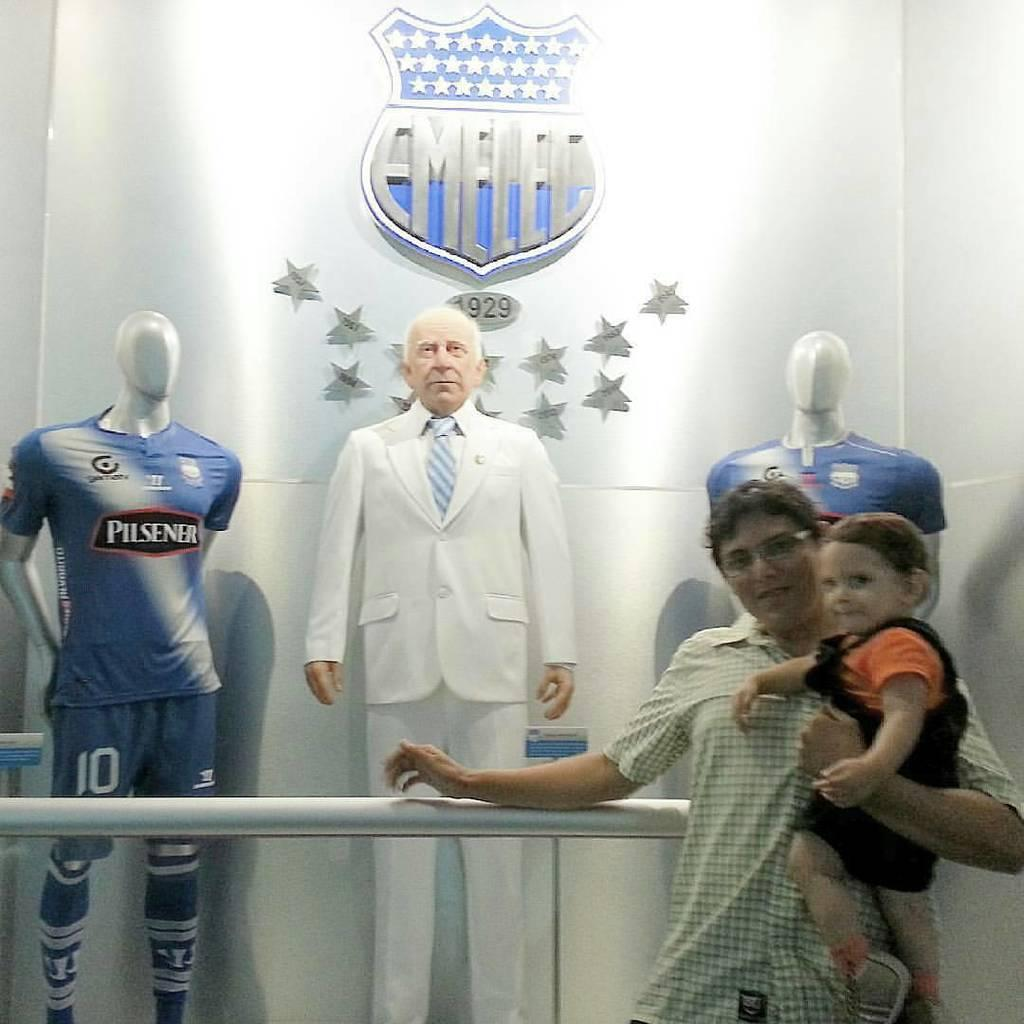<image>
Offer a succinct explanation of the picture presented. A man and small child pose in front of a Emelec display containing the likeness of a man in a suit and team uniforms with Pilsener on the front. 